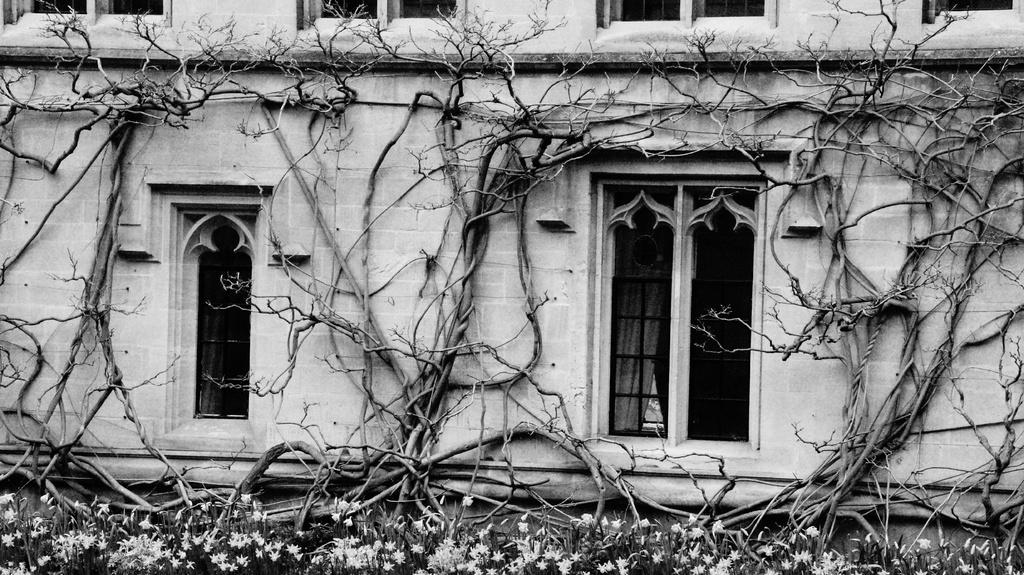What is the color scheme of the image? The image is black and white. What type of structure can be seen in the image? There is a building in the image. What is located in front of the building? There are trees in front of the building. What type of flora is present in the image? Flowers and plants are visible in the image. Can you see a volleyball game happening in the image? No, there is no volleyball game present in the image. How many people are jumping in the image? There are no people jumping in the image. 